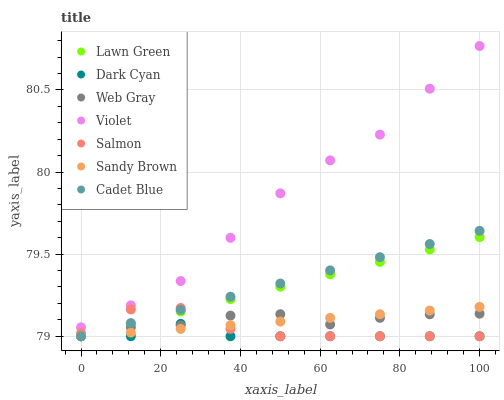Does Dark Cyan have the minimum area under the curve?
Answer yes or no. Yes. Does Violet have the maximum area under the curve?
Answer yes or no. Yes. Does Web Gray have the minimum area under the curve?
Answer yes or no. No. Does Web Gray have the maximum area under the curve?
Answer yes or no. No. Is Lawn Green the smoothest?
Answer yes or no. Yes. Is Salmon the roughest?
Answer yes or no. Yes. Is Web Gray the smoothest?
Answer yes or no. No. Is Web Gray the roughest?
Answer yes or no. No. Does Lawn Green have the lowest value?
Answer yes or no. Yes. Does Violet have the lowest value?
Answer yes or no. No. Does Violet have the highest value?
Answer yes or no. Yes. Does Web Gray have the highest value?
Answer yes or no. No. Is Dark Cyan less than Violet?
Answer yes or no. Yes. Is Violet greater than Lawn Green?
Answer yes or no. Yes. Does Cadet Blue intersect Web Gray?
Answer yes or no. Yes. Is Cadet Blue less than Web Gray?
Answer yes or no. No. Is Cadet Blue greater than Web Gray?
Answer yes or no. No. Does Dark Cyan intersect Violet?
Answer yes or no. No. 